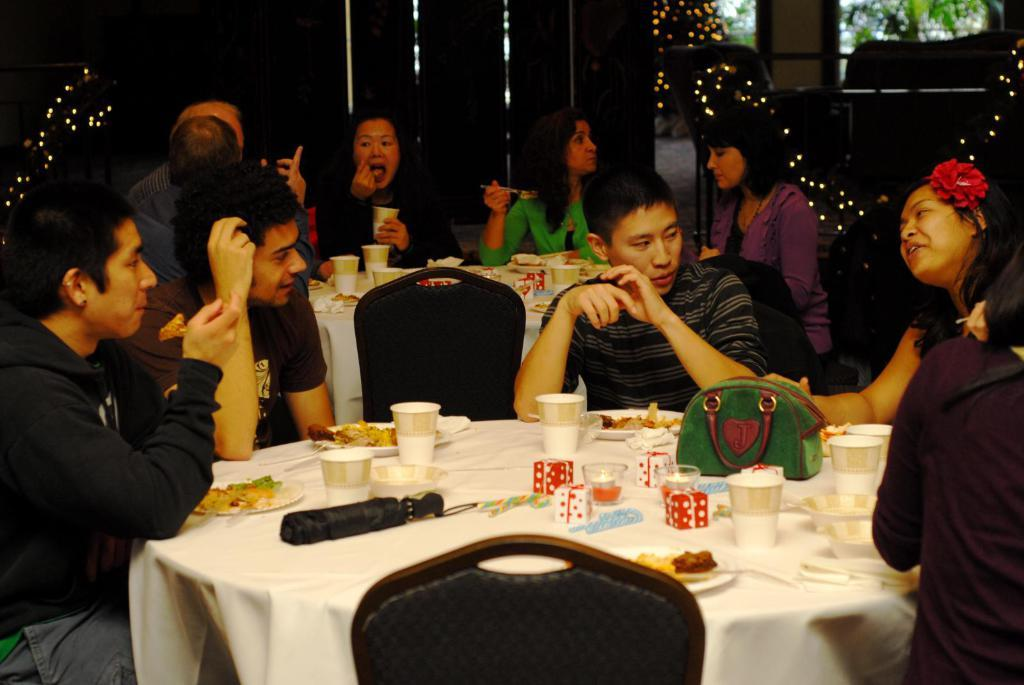How many people are in the image? There is a group of people in the image. What are the people doing in the image? The people are sitting on chairs. Where are the chairs located in relation to the table? The chairs are in front of a table. What can be found on the table? There are objects on the table. How does the queen feel about the comfort of the chairs in the image? There is no queen present in the image, and therefore her feelings about the chairs cannot be determined. 